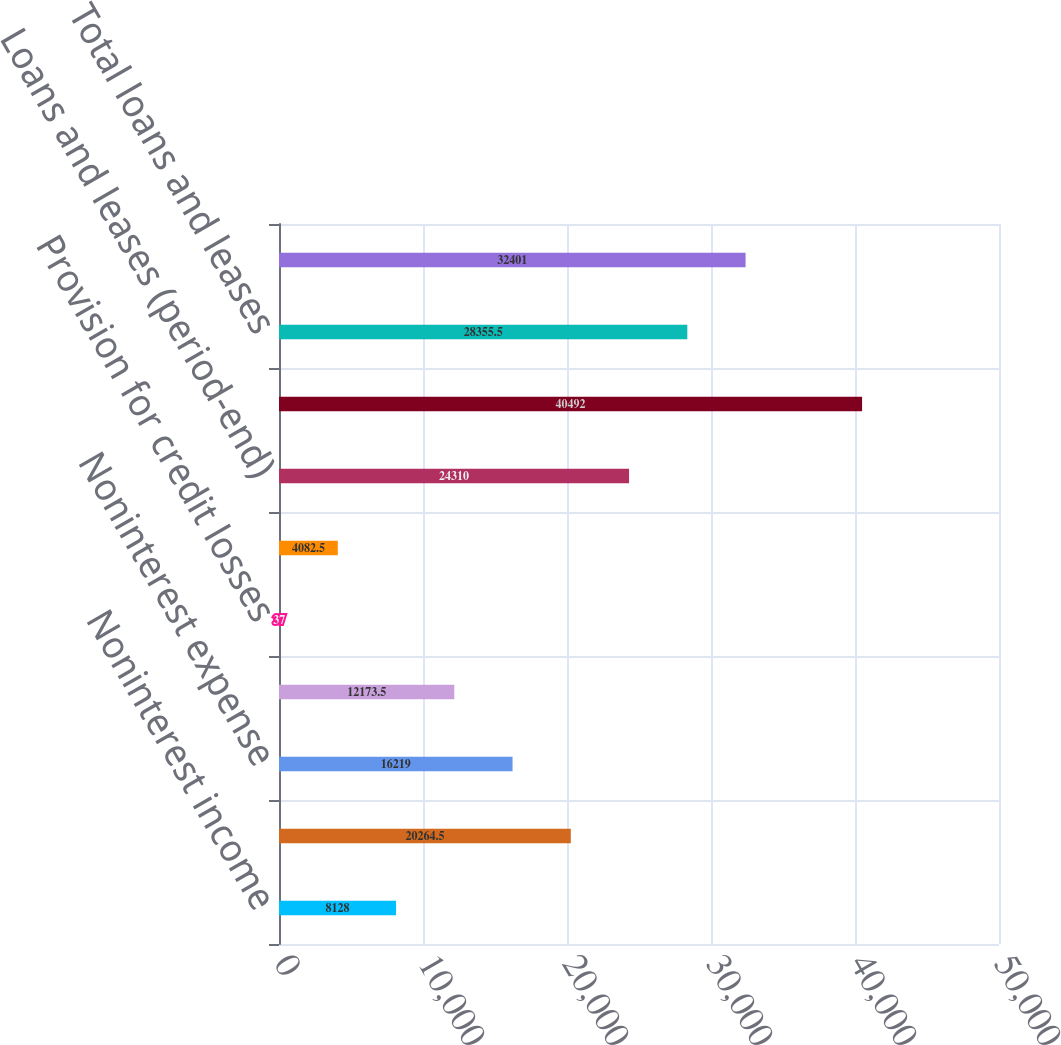Convert chart. <chart><loc_0><loc_0><loc_500><loc_500><bar_chart><fcel>Noninterest income<fcel>Total revenue<fcel>Noninterest expense<fcel>Profit before provision for<fcel>Provision for credit losses<fcel>Income before income tax<fcel>Loans and leases (period-end)<fcel>Total assets<fcel>Total loans and leases<fcel>Deposits<nl><fcel>8128<fcel>20264.5<fcel>16219<fcel>12173.5<fcel>37<fcel>4082.5<fcel>24310<fcel>40492<fcel>28355.5<fcel>32401<nl></chart> 